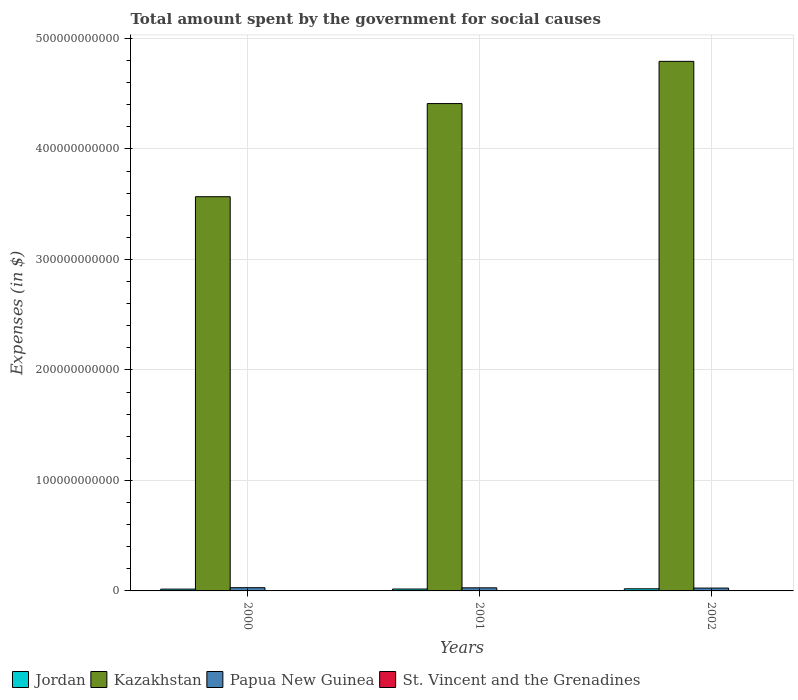Are the number of bars per tick equal to the number of legend labels?
Offer a terse response. Yes. What is the amount spent for social causes by the government in Jordan in 2001?
Ensure brevity in your answer.  1.72e+09. Across all years, what is the maximum amount spent for social causes by the government in Kazakhstan?
Make the answer very short. 4.79e+11. Across all years, what is the minimum amount spent for social causes by the government in St. Vincent and the Grenadines?
Your response must be concise. 2.41e+08. In which year was the amount spent for social causes by the government in Kazakhstan maximum?
Keep it short and to the point. 2002. In which year was the amount spent for social causes by the government in St. Vincent and the Grenadines minimum?
Offer a terse response. 2000. What is the total amount spent for social causes by the government in Kazakhstan in the graph?
Provide a short and direct response. 1.28e+12. What is the difference between the amount spent for social causes by the government in Papua New Guinea in 2000 and that in 2002?
Offer a very short reply. 3.50e+08. What is the difference between the amount spent for social causes by the government in Jordan in 2000 and the amount spent for social causes by the government in Papua New Guinea in 2002?
Your answer should be compact. -9.48e+08. What is the average amount spent for social causes by the government in Papua New Guinea per year?
Give a very brief answer. 2.77e+09. In the year 2000, what is the difference between the amount spent for social causes by the government in Kazakhstan and amount spent for social causes by the government in St. Vincent and the Grenadines?
Your answer should be compact. 3.57e+11. In how many years, is the amount spent for social causes by the government in Jordan greater than 100000000000 $?
Offer a terse response. 0. What is the ratio of the amount spent for social causes by the government in Jordan in 2000 to that in 2001?
Keep it short and to the point. 0.95. Is the amount spent for social causes by the government in Papua New Guinea in 2001 less than that in 2002?
Offer a very short reply. No. Is the difference between the amount spent for social causes by the government in Kazakhstan in 2001 and 2002 greater than the difference between the amount spent for social causes by the government in St. Vincent and the Grenadines in 2001 and 2002?
Make the answer very short. No. What is the difference between the highest and the second highest amount spent for social causes by the government in Papua New Guinea?
Offer a terse response. 1.26e+08. What is the difference between the highest and the lowest amount spent for social causes by the government in Jordan?
Ensure brevity in your answer.  2.98e+08. In how many years, is the amount spent for social causes by the government in Papua New Guinea greater than the average amount spent for social causes by the government in Papua New Guinea taken over all years?
Provide a short and direct response. 2. Is it the case that in every year, the sum of the amount spent for social causes by the government in St. Vincent and the Grenadines and amount spent for social causes by the government in Papua New Guinea is greater than the sum of amount spent for social causes by the government in Jordan and amount spent for social causes by the government in Kazakhstan?
Your answer should be very brief. Yes. What does the 1st bar from the left in 2000 represents?
Give a very brief answer. Jordan. What does the 3rd bar from the right in 2000 represents?
Your answer should be very brief. Kazakhstan. Is it the case that in every year, the sum of the amount spent for social causes by the government in St. Vincent and the Grenadines and amount spent for social causes by the government in Kazakhstan is greater than the amount spent for social causes by the government in Papua New Guinea?
Your answer should be very brief. Yes. How many years are there in the graph?
Give a very brief answer. 3. What is the difference between two consecutive major ticks on the Y-axis?
Offer a very short reply. 1.00e+11. Are the values on the major ticks of Y-axis written in scientific E-notation?
Offer a terse response. No. Where does the legend appear in the graph?
Your answer should be compact. Bottom left. What is the title of the graph?
Give a very brief answer. Total amount spent by the government for social causes. What is the label or title of the Y-axis?
Offer a terse response. Expenses (in $). What is the Expenses (in $) of Jordan in 2000?
Give a very brief answer. 1.63e+09. What is the Expenses (in $) of Kazakhstan in 2000?
Offer a terse response. 3.57e+11. What is the Expenses (in $) of Papua New Guinea in 2000?
Offer a terse response. 2.93e+09. What is the Expenses (in $) of St. Vincent and the Grenadines in 2000?
Give a very brief answer. 2.41e+08. What is the Expenses (in $) of Jordan in 2001?
Provide a succinct answer. 1.72e+09. What is the Expenses (in $) of Kazakhstan in 2001?
Provide a succinct answer. 4.41e+11. What is the Expenses (in $) in Papua New Guinea in 2001?
Provide a short and direct response. 2.80e+09. What is the Expenses (in $) of St. Vincent and the Grenadines in 2001?
Provide a short and direct response. 2.59e+08. What is the Expenses (in $) of Jordan in 2002?
Your response must be concise. 1.93e+09. What is the Expenses (in $) in Kazakhstan in 2002?
Ensure brevity in your answer.  4.79e+11. What is the Expenses (in $) of Papua New Guinea in 2002?
Give a very brief answer. 2.58e+09. What is the Expenses (in $) of St. Vincent and the Grenadines in 2002?
Your answer should be compact. 2.73e+08. Across all years, what is the maximum Expenses (in $) of Jordan?
Keep it short and to the point. 1.93e+09. Across all years, what is the maximum Expenses (in $) of Kazakhstan?
Provide a short and direct response. 4.79e+11. Across all years, what is the maximum Expenses (in $) of Papua New Guinea?
Your answer should be very brief. 2.93e+09. Across all years, what is the maximum Expenses (in $) of St. Vincent and the Grenadines?
Provide a succinct answer. 2.73e+08. Across all years, what is the minimum Expenses (in $) of Jordan?
Make the answer very short. 1.63e+09. Across all years, what is the minimum Expenses (in $) in Kazakhstan?
Keep it short and to the point. 3.57e+11. Across all years, what is the minimum Expenses (in $) of Papua New Guinea?
Give a very brief answer. 2.58e+09. Across all years, what is the minimum Expenses (in $) of St. Vincent and the Grenadines?
Give a very brief answer. 2.41e+08. What is the total Expenses (in $) of Jordan in the graph?
Offer a very short reply. 5.27e+09. What is the total Expenses (in $) in Kazakhstan in the graph?
Give a very brief answer. 1.28e+12. What is the total Expenses (in $) in Papua New Guinea in the graph?
Give a very brief answer. 8.30e+09. What is the total Expenses (in $) in St. Vincent and the Grenadines in the graph?
Provide a succinct answer. 7.72e+08. What is the difference between the Expenses (in $) of Jordan in 2000 and that in 2001?
Give a very brief answer. -9.06e+07. What is the difference between the Expenses (in $) of Kazakhstan in 2000 and that in 2001?
Keep it short and to the point. -8.43e+1. What is the difference between the Expenses (in $) of Papua New Guinea in 2000 and that in 2001?
Provide a short and direct response. 1.26e+08. What is the difference between the Expenses (in $) in St. Vincent and the Grenadines in 2000 and that in 2001?
Offer a very short reply. -1.81e+07. What is the difference between the Expenses (in $) in Jordan in 2000 and that in 2002?
Ensure brevity in your answer.  -2.98e+08. What is the difference between the Expenses (in $) in Kazakhstan in 2000 and that in 2002?
Offer a terse response. -1.23e+11. What is the difference between the Expenses (in $) of Papua New Guinea in 2000 and that in 2002?
Provide a succinct answer. 3.50e+08. What is the difference between the Expenses (in $) of St. Vincent and the Grenadines in 2000 and that in 2002?
Your answer should be very brief. -3.25e+07. What is the difference between the Expenses (in $) in Jordan in 2001 and that in 2002?
Your answer should be compact. -2.08e+08. What is the difference between the Expenses (in $) in Kazakhstan in 2001 and that in 2002?
Offer a terse response. -3.82e+1. What is the difference between the Expenses (in $) in Papua New Guinea in 2001 and that in 2002?
Offer a very short reply. 2.24e+08. What is the difference between the Expenses (in $) in St. Vincent and the Grenadines in 2001 and that in 2002?
Make the answer very short. -1.44e+07. What is the difference between the Expenses (in $) in Jordan in 2000 and the Expenses (in $) in Kazakhstan in 2001?
Give a very brief answer. -4.39e+11. What is the difference between the Expenses (in $) of Jordan in 2000 and the Expenses (in $) of Papua New Guinea in 2001?
Your answer should be very brief. -1.17e+09. What is the difference between the Expenses (in $) of Jordan in 2000 and the Expenses (in $) of St. Vincent and the Grenadines in 2001?
Offer a terse response. 1.37e+09. What is the difference between the Expenses (in $) in Kazakhstan in 2000 and the Expenses (in $) in Papua New Guinea in 2001?
Your answer should be very brief. 3.54e+11. What is the difference between the Expenses (in $) in Kazakhstan in 2000 and the Expenses (in $) in St. Vincent and the Grenadines in 2001?
Provide a succinct answer. 3.56e+11. What is the difference between the Expenses (in $) of Papua New Guinea in 2000 and the Expenses (in $) of St. Vincent and the Grenadines in 2001?
Ensure brevity in your answer.  2.67e+09. What is the difference between the Expenses (in $) of Jordan in 2000 and the Expenses (in $) of Kazakhstan in 2002?
Offer a very short reply. -4.78e+11. What is the difference between the Expenses (in $) of Jordan in 2000 and the Expenses (in $) of Papua New Guinea in 2002?
Provide a succinct answer. -9.48e+08. What is the difference between the Expenses (in $) in Jordan in 2000 and the Expenses (in $) in St. Vincent and the Grenadines in 2002?
Offer a very short reply. 1.35e+09. What is the difference between the Expenses (in $) in Kazakhstan in 2000 and the Expenses (in $) in Papua New Guinea in 2002?
Ensure brevity in your answer.  3.54e+11. What is the difference between the Expenses (in $) in Kazakhstan in 2000 and the Expenses (in $) in St. Vincent and the Grenadines in 2002?
Your answer should be compact. 3.56e+11. What is the difference between the Expenses (in $) of Papua New Guinea in 2000 and the Expenses (in $) of St. Vincent and the Grenadines in 2002?
Provide a succinct answer. 2.65e+09. What is the difference between the Expenses (in $) of Jordan in 2001 and the Expenses (in $) of Kazakhstan in 2002?
Make the answer very short. -4.78e+11. What is the difference between the Expenses (in $) in Jordan in 2001 and the Expenses (in $) in Papua New Guinea in 2002?
Offer a very short reply. -8.58e+08. What is the difference between the Expenses (in $) of Jordan in 2001 and the Expenses (in $) of St. Vincent and the Grenadines in 2002?
Your answer should be compact. 1.44e+09. What is the difference between the Expenses (in $) in Kazakhstan in 2001 and the Expenses (in $) in Papua New Guinea in 2002?
Provide a short and direct response. 4.38e+11. What is the difference between the Expenses (in $) of Kazakhstan in 2001 and the Expenses (in $) of St. Vincent and the Grenadines in 2002?
Ensure brevity in your answer.  4.41e+11. What is the difference between the Expenses (in $) in Papua New Guinea in 2001 and the Expenses (in $) in St. Vincent and the Grenadines in 2002?
Your answer should be compact. 2.53e+09. What is the average Expenses (in $) of Jordan per year?
Provide a succinct answer. 1.76e+09. What is the average Expenses (in $) of Kazakhstan per year?
Your answer should be compact. 4.26e+11. What is the average Expenses (in $) of Papua New Guinea per year?
Keep it short and to the point. 2.77e+09. What is the average Expenses (in $) in St. Vincent and the Grenadines per year?
Offer a very short reply. 2.57e+08. In the year 2000, what is the difference between the Expenses (in $) of Jordan and Expenses (in $) of Kazakhstan?
Ensure brevity in your answer.  -3.55e+11. In the year 2000, what is the difference between the Expenses (in $) in Jordan and Expenses (in $) in Papua New Guinea?
Your answer should be very brief. -1.30e+09. In the year 2000, what is the difference between the Expenses (in $) of Jordan and Expenses (in $) of St. Vincent and the Grenadines?
Offer a terse response. 1.39e+09. In the year 2000, what is the difference between the Expenses (in $) of Kazakhstan and Expenses (in $) of Papua New Guinea?
Your answer should be very brief. 3.54e+11. In the year 2000, what is the difference between the Expenses (in $) in Kazakhstan and Expenses (in $) in St. Vincent and the Grenadines?
Keep it short and to the point. 3.57e+11. In the year 2000, what is the difference between the Expenses (in $) in Papua New Guinea and Expenses (in $) in St. Vincent and the Grenadines?
Give a very brief answer. 2.68e+09. In the year 2001, what is the difference between the Expenses (in $) of Jordan and Expenses (in $) of Kazakhstan?
Provide a succinct answer. -4.39e+11. In the year 2001, what is the difference between the Expenses (in $) in Jordan and Expenses (in $) in Papua New Guinea?
Your response must be concise. -1.08e+09. In the year 2001, what is the difference between the Expenses (in $) in Jordan and Expenses (in $) in St. Vincent and the Grenadines?
Your answer should be very brief. 1.46e+09. In the year 2001, what is the difference between the Expenses (in $) of Kazakhstan and Expenses (in $) of Papua New Guinea?
Your answer should be very brief. 4.38e+11. In the year 2001, what is the difference between the Expenses (in $) in Kazakhstan and Expenses (in $) in St. Vincent and the Grenadines?
Give a very brief answer. 4.41e+11. In the year 2001, what is the difference between the Expenses (in $) in Papua New Guinea and Expenses (in $) in St. Vincent and the Grenadines?
Your response must be concise. 2.54e+09. In the year 2002, what is the difference between the Expenses (in $) in Jordan and Expenses (in $) in Kazakhstan?
Provide a succinct answer. -4.77e+11. In the year 2002, what is the difference between the Expenses (in $) in Jordan and Expenses (in $) in Papua New Guinea?
Your response must be concise. -6.50e+08. In the year 2002, what is the difference between the Expenses (in $) in Jordan and Expenses (in $) in St. Vincent and the Grenadines?
Your answer should be compact. 1.65e+09. In the year 2002, what is the difference between the Expenses (in $) of Kazakhstan and Expenses (in $) of Papua New Guinea?
Ensure brevity in your answer.  4.77e+11. In the year 2002, what is the difference between the Expenses (in $) of Kazakhstan and Expenses (in $) of St. Vincent and the Grenadines?
Ensure brevity in your answer.  4.79e+11. In the year 2002, what is the difference between the Expenses (in $) in Papua New Guinea and Expenses (in $) in St. Vincent and the Grenadines?
Keep it short and to the point. 2.30e+09. What is the ratio of the Expenses (in $) of Jordan in 2000 to that in 2001?
Your answer should be compact. 0.95. What is the ratio of the Expenses (in $) of Kazakhstan in 2000 to that in 2001?
Ensure brevity in your answer.  0.81. What is the ratio of the Expenses (in $) of Papua New Guinea in 2000 to that in 2001?
Your answer should be very brief. 1.05. What is the ratio of the Expenses (in $) in St. Vincent and the Grenadines in 2000 to that in 2001?
Ensure brevity in your answer.  0.93. What is the ratio of the Expenses (in $) in Jordan in 2000 to that in 2002?
Your answer should be compact. 0.84. What is the ratio of the Expenses (in $) of Kazakhstan in 2000 to that in 2002?
Give a very brief answer. 0.74. What is the ratio of the Expenses (in $) in Papua New Guinea in 2000 to that in 2002?
Offer a very short reply. 1.14. What is the ratio of the Expenses (in $) of St. Vincent and the Grenadines in 2000 to that in 2002?
Make the answer very short. 0.88. What is the ratio of the Expenses (in $) in Jordan in 2001 to that in 2002?
Make the answer very short. 0.89. What is the ratio of the Expenses (in $) in Kazakhstan in 2001 to that in 2002?
Provide a succinct answer. 0.92. What is the ratio of the Expenses (in $) in Papua New Guinea in 2001 to that in 2002?
Ensure brevity in your answer.  1.09. What is the ratio of the Expenses (in $) in St. Vincent and the Grenadines in 2001 to that in 2002?
Keep it short and to the point. 0.95. What is the difference between the highest and the second highest Expenses (in $) of Jordan?
Give a very brief answer. 2.08e+08. What is the difference between the highest and the second highest Expenses (in $) in Kazakhstan?
Keep it short and to the point. 3.82e+1. What is the difference between the highest and the second highest Expenses (in $) of Papua New Guinea?
Keep it short and to the point. 1.26e+08. What is the difference between the highest and the second highest Expenses (in $) of St. Vincent and the Grenadines?
Make the answer very short. 1.44e+07. What is the difference between the highest and the lowest Expenses (in $) in Jordan?
Your response must be concise. 2.98e+08. What is the difference between the highest and the lowest Expenses (in $) in Kazakhstan?
Give a very brief answer. 1.23e+11. What is the difference between the highest and the lowest Expenses (in $) of Papua New Guinea?
Provide a succinct answer. 3.50e+08. What is the difference between the highest and the lowest Expenses (in $) in St. Vincent and the Grenadines?
Ensure brevity in your answer.  3.25e+07. 